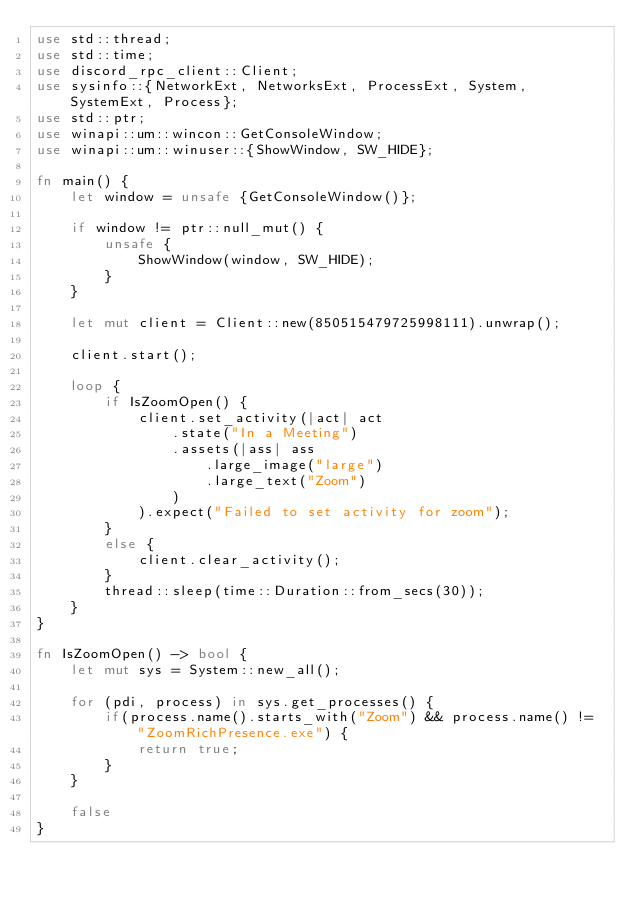<code> <loc_0><loc_0><loc_500><loc_500><_Rust_>use std::thread;
use std::time;
use discord_rpc_client::Client;
use sysinfo::{NetworkExt, NetworksExt, ProcessExt, System, SystemExt, Process};
use std::ptr;
use winapi::um::wincon::GetConsoleWindow;
use winapi::um::winuser::{ShowWindow, SW_HIDE};

fn main() {
    let window = unsafe {GetConsoleWindow()};

    if window != ptr::null_mut() {
        unsafe {
            ShowWindow(window, SW_HIDE);
        }
    }

    let mut client = Client::new(850515479725998111).unwrap();

    client.start();

    loop {
        if IsZoomOpen() {
            client.set_activity(|act| act
                .state("In a Meeting")
                .assets(|ass| ass
                    .large_image("large")
                    .large_text("Zoom")
                )
            ).expect("Failed to set activity for zoom");
        }
        else {
            client.clear_activity();
        }
        thread::sleep(time::Duration::from_secs(30));
    }
}

fn IsZoomOpen() -> bool {
    let mut sys = System::new_all();

    for (pdi, process) in sys.get_processes() {
        if(process.name().starts_with("Zoom") && process.name() != "ZoomRichPresence.exe") {
            return true;
        }
    }

    false
}
</code> 